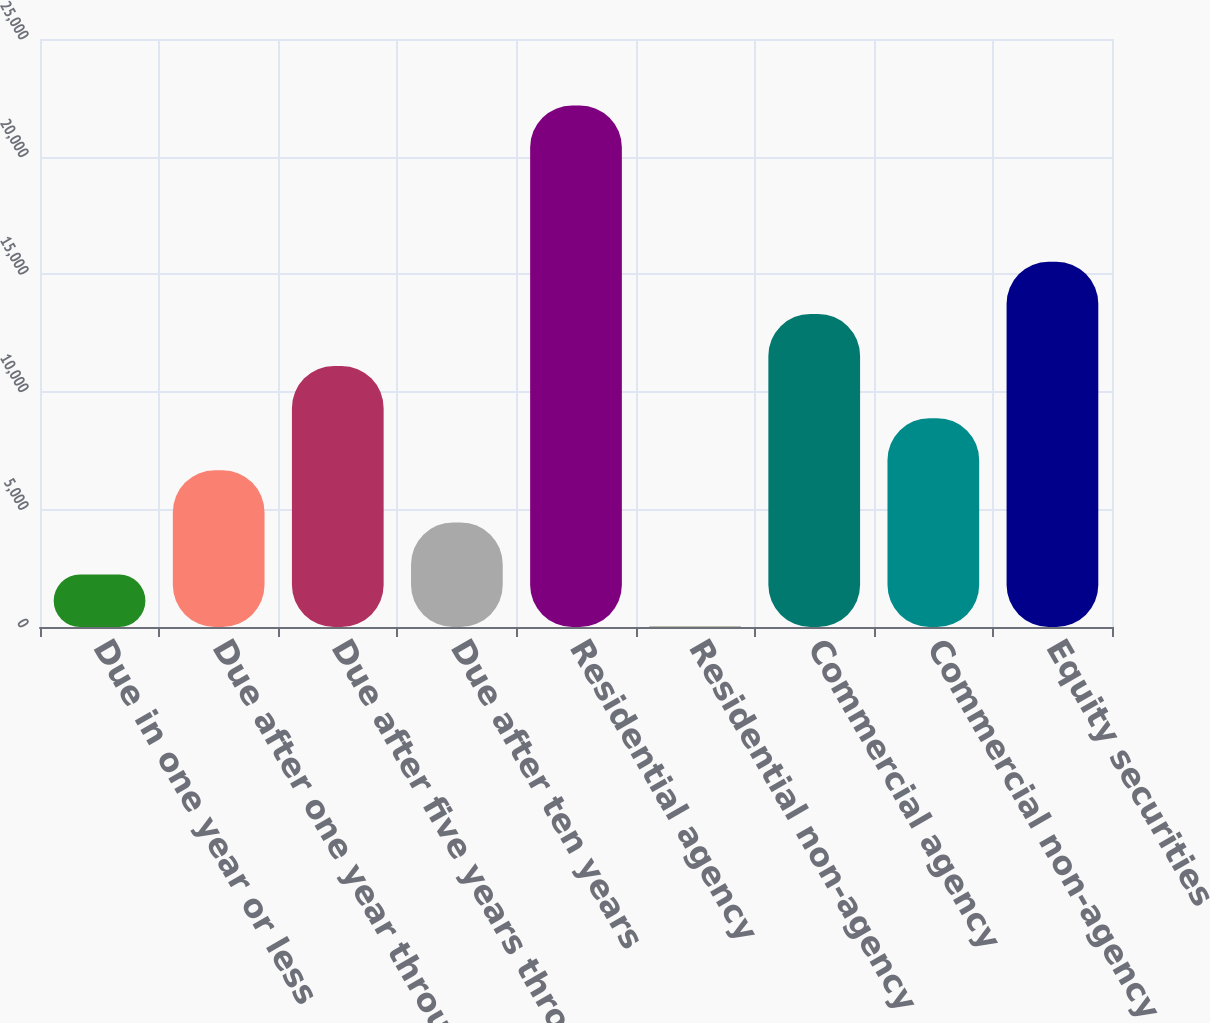<chart> <loc_0><loc_0><loc_500><loc_500><bar_chart><fcel>Due in one year or less<fcel>Due after one year through<fcel>Due after five years through<fcel>Due after ten years<fcel>Residential agency<fcel>Residential non-agency<fcel>Commercial agency<fcel>Commercial non-agency<fcel>Equity securities<nl><fcel>2231.9<fcel>6663.7<fcel>11095.5<fcel>4447.8<fcel>22175<fcel>16<fcel>13311.4<fcel>8879.6<fcel>15527.3<nl></chart> 